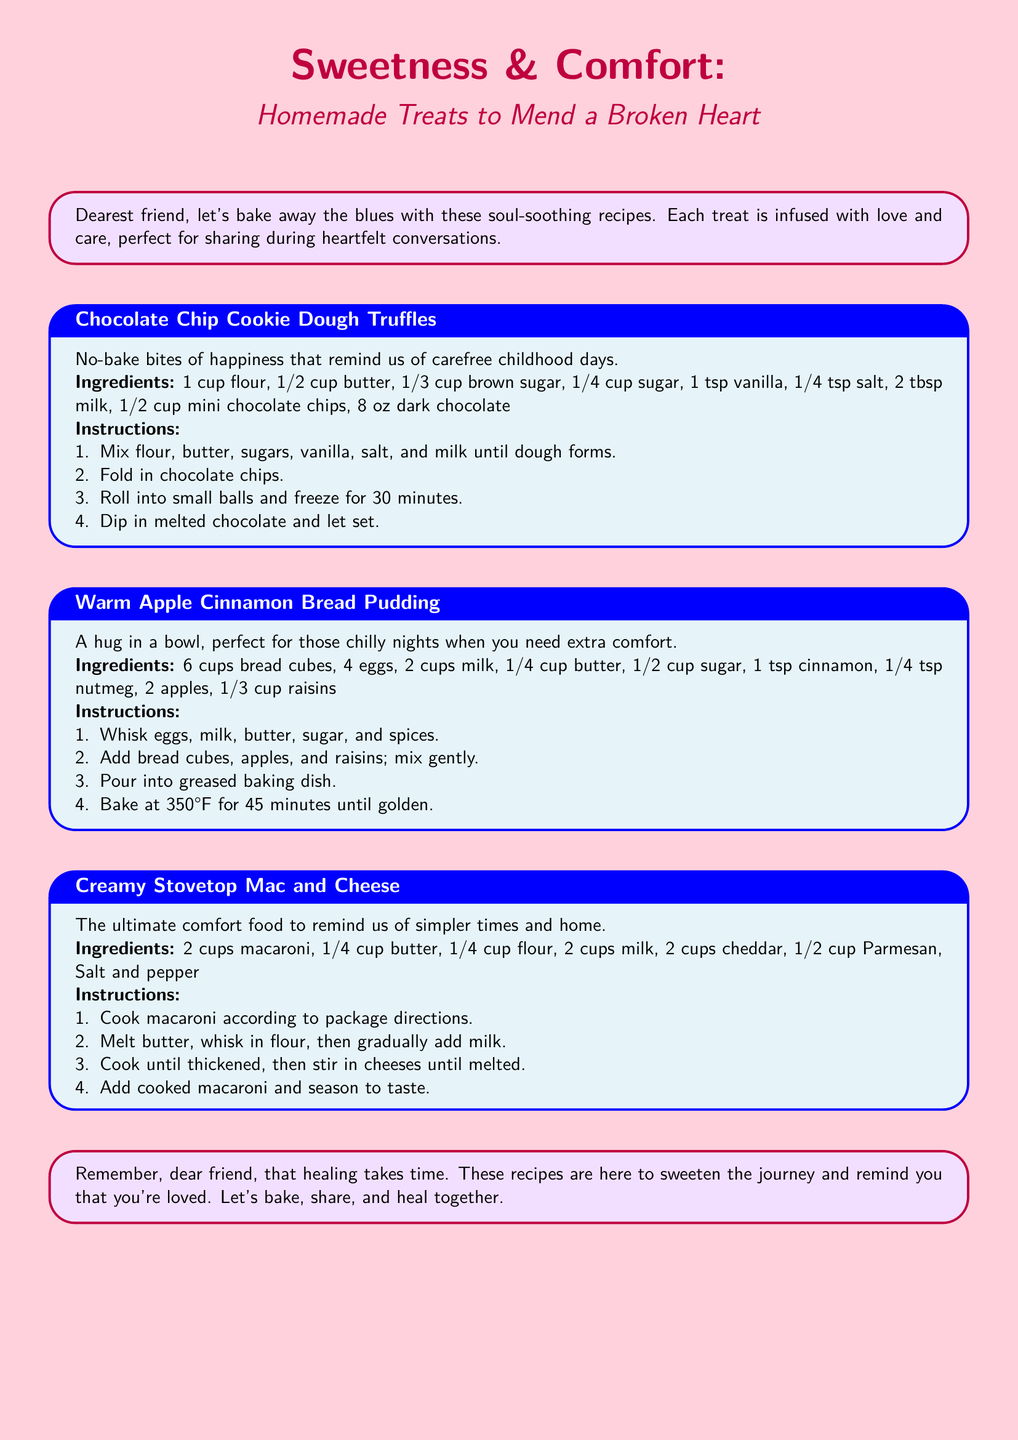What is the title of the document? The title is prominently displayed at the top of the document, introducing its theme of comfort.
Answer: Sweetness & Comfort: Homemade Treats to Mend a Broken Heart How many recipes are included in the document? Each recipe is presented within its own colored box; there are three such boxes in the document.
Answer: 3 What is the main ingredient in Chocolate Chip Cookie Dough Truffles? The recipe outlines the key components of the dessert, emphasizing flour as one of the necessary ingredients.
Answer: Flour What temperature should Warm Apple Cinnamon Bread Pudding be baked at? The instructions specify the baking conditions for this comforting dessert.
Answer: 350°F What type of cheese is used in Creamy Stovetop Mac and Cheese? The ingredient list mentions two varieties of cheese used in the recipe.
Answer: Cheddar and Parmesan What is described as “a hug in a bowl”? This phrase emphasizes the comforting nature of one of the recipes included in the document.
Answer: Warm Apple Cinnamon Bread Pudding How long should Chocolate Chip Cookie Dough Truffles be frozen? The instructions provide a specific freezing duration for the preparation of this treat.
Answer: 30 minutes What emotional theme is addressed in the introduction of the document? The introduction speaks to the healing process and the emotional support provided through cooking.
Answer: Healing What type of document is this? The layout, structure, and content suggest its purpose as a collection of recipes aimed at comfort.
Answer: Recipe catalog 